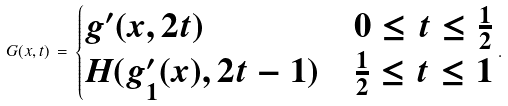<formula> <loc_0><loc_0><loc_500><loc_500>G ( x , t ) \, = \, \begin{cases} g ^ { \prime } ( x , 2 t ) & 0 \leq t \leq \frac { 1 } { 2 } \\ H ( g ^ { \prime } _ { 1 } ( x ) , 2 t - 1 ) & \frac { 1 } { 2 } \leq t \leq 1 \end{cases} .</formula> 